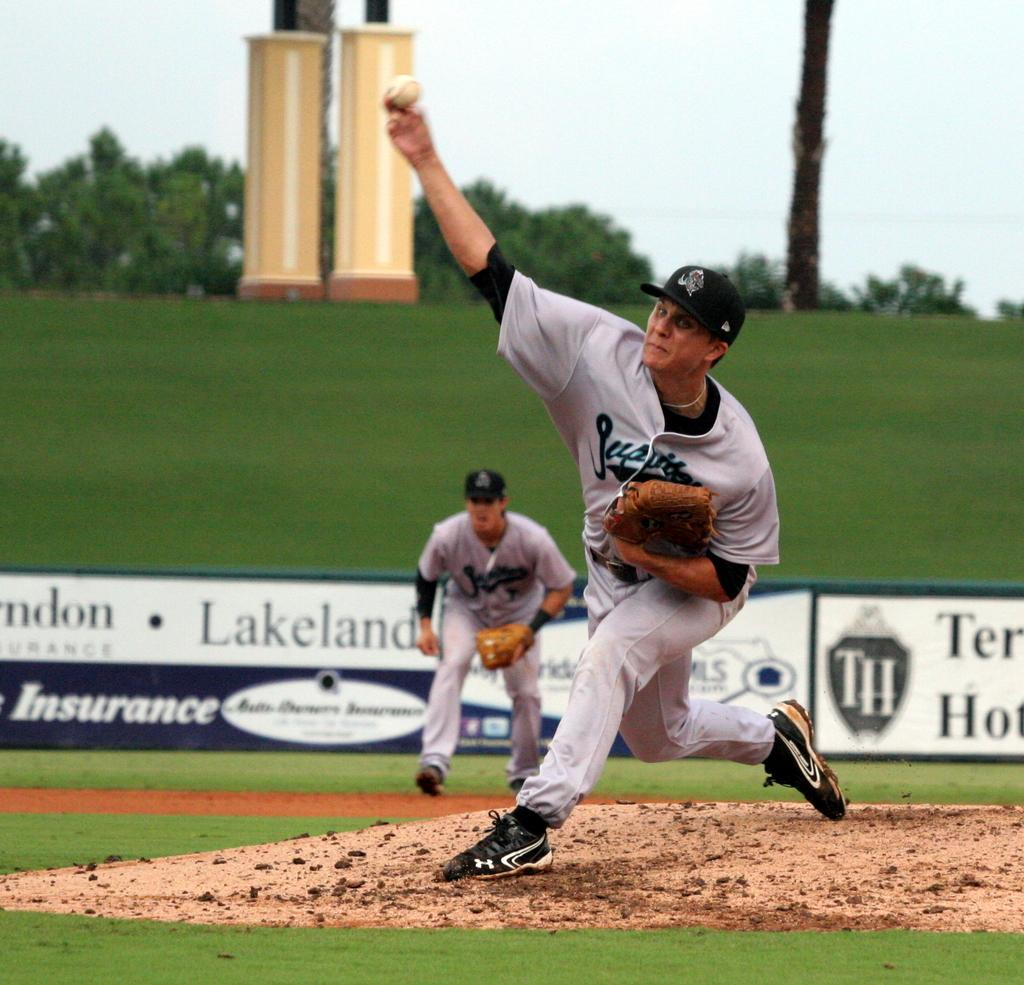<image>
Summarize the visual content of the image. People are playing baseball in front of an advertisement for Lakeland and an insurance company. 